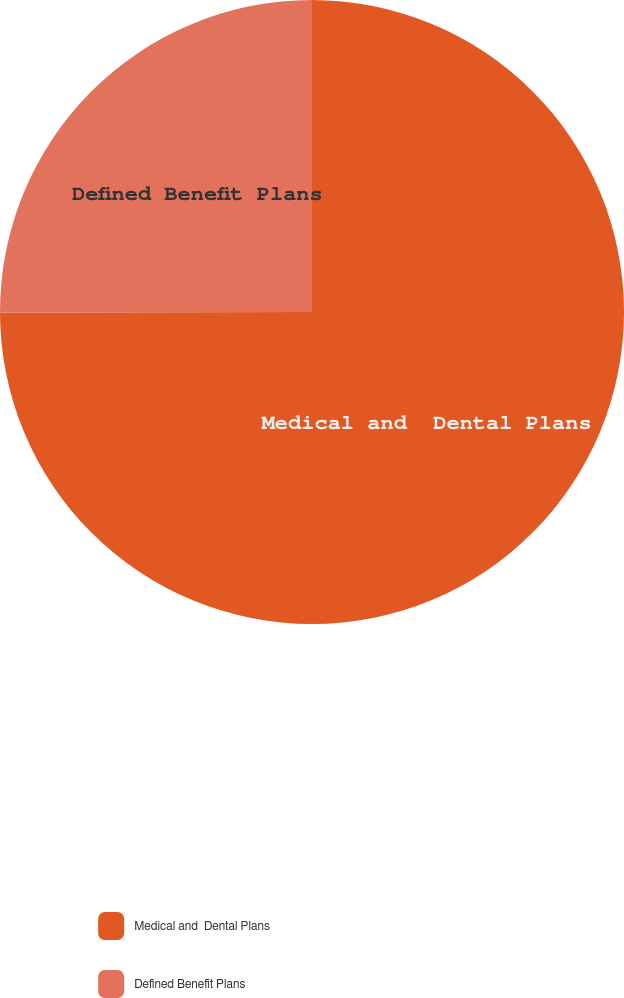Convert chart to OTSL. <chart><loc_0><loc_0><loc_500><loc_500><pie_chart><fcel>Medical and  Dental Plans<fcel>Defined Benefit Plans<nl><fcel>74.97%<fcel>25.03%<nl></chart> 